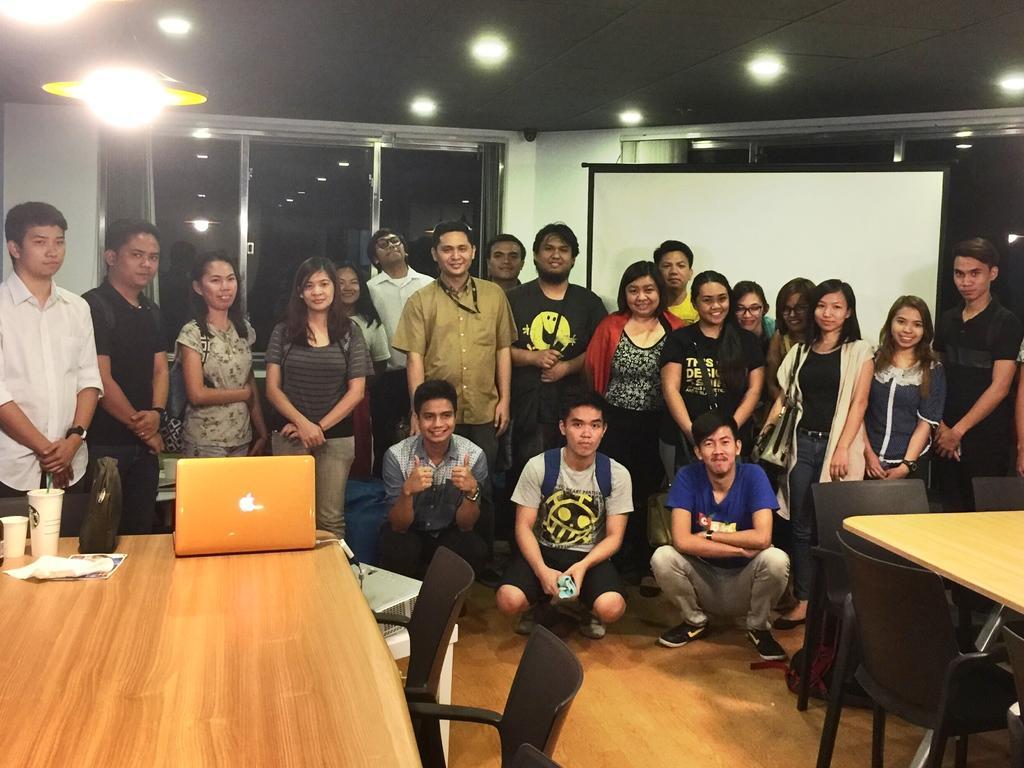Please provide a concise description of this image. In this picture there are several people standing in front of a white screen projector. There are two tables on the either side of the image. In the background there are glass windows and lights attached. 